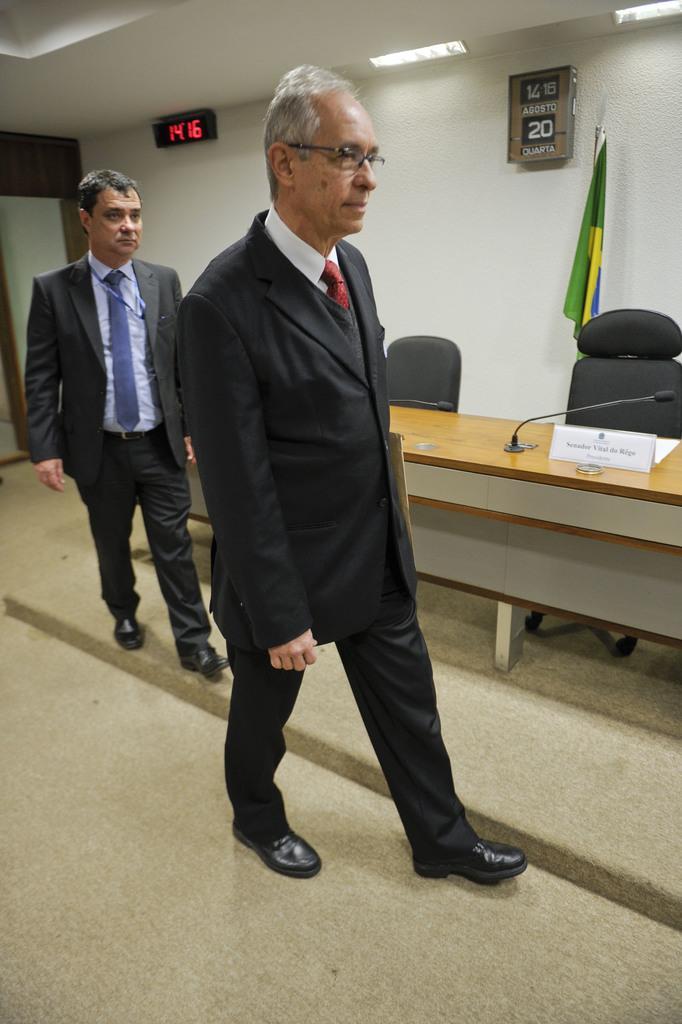Can you describe this image briefly? These two persons wore suits and walking, as there is a movement in there legs. These are chairs. In-front of these chairs there is a table, on this table there is a name board and mic. A calendar and a digital clock on wall. This is flag. 